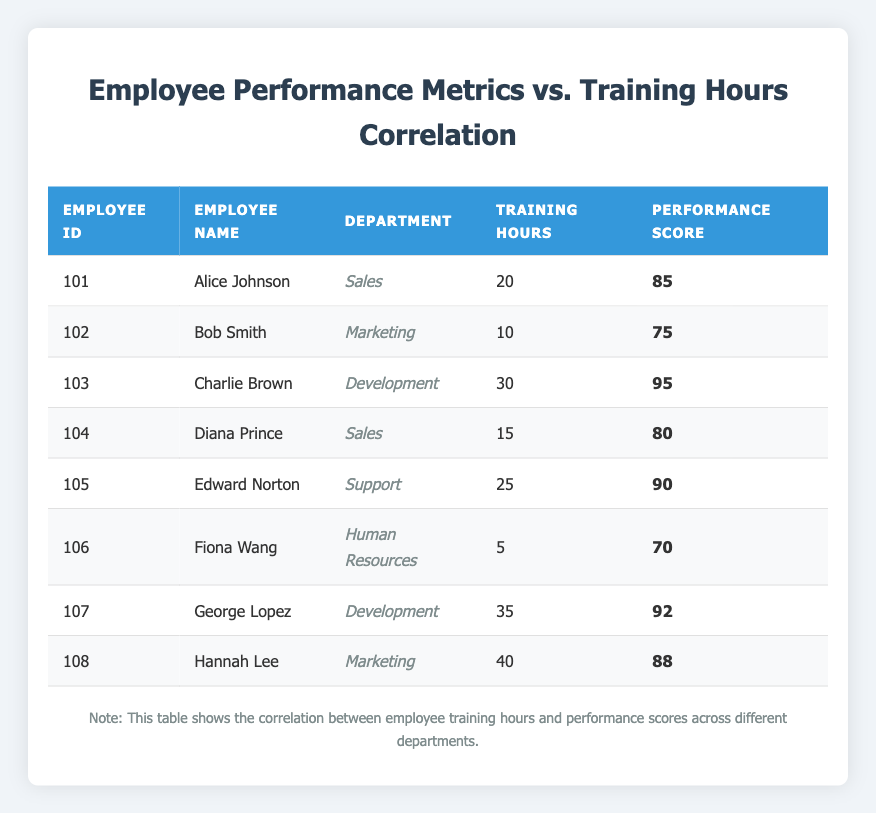What is the Performance Score of Fiona Wang? From the table, look for Fiona Wang's entry, which is listed under Employee ID 106. Her Performance Score is in the corresponding column next to her name. The score is 70.
Answer: 70 What is the Training Hours for the employee with the highest Performance Score? Identify the highest Performance Score in the table, which belongs to Charlie Brown with a score of 95. Next to his name in the Training Hours column, it shows he has 30 Training Hours.
Answer: 30 How many employees have a Performance Score greater than 80? Review the Performance Scores in the table. The employees with scores greater than 80 are: Alice Johnson (85), Charlie Brown (95), Edward Norton (90), George Lopez (92), and Hannah Lee (88). That's a total of 5 employees.
Answer: 5 What are the average Training Hours for employees in the Sales department? Identify the employees in the Sales department, which are Alice Johnson (20 hours) and Diana Prince (15 hours). To find the average, sum their Training Hours (20 + 15 = 35) and divide by the number of employees (2). The average is 35 / 2 = 17.5.
Answer: 17.5 Is George Lopez's Performance Score higher than Bob Smith's? Look at the Performance Scores of George Lopez and Bob Smith from the table. George Lopez has a score of 92 and Bob Smith has a score of 75. Since 92 is greater than 75, the answer is yes.
Answer: Yes How many Training Hours does the employee in Marketing with the lowest Performance Score have? In the Marketing department, identify the employees: Bob Smith has 10 Training Hours and a score of 75, while Hannah Lee has 40 Training Hours with a score of 88. Bob Smith has the lowest score, so we check his Training Hours, which is 10.
Answer: 10 What is the difference in Training Hours between the employee with the highest and lowest Performance Scores? From the table, the highest Performance Score is Charlie Brown with 30 Training Hours, and the lowest Performance Score is Fiona Wang with 5 Training Hours. The difference is calculated as 35 (30 - 5 = 25 hours).
Answer: 25 How many employees have more than 20 Training Hours? Go through the Training Hours column. Employees with more than 20 Training Hours are Charlie Brown (30), Edward Norton (25), George Lopez (35), and Hannah Lee (40). This totals to 4 employees.
Answer: 4 What is the Performance Score of the employee with the most Training Hours? From the table, Hannah Lee has the most Training Hours with 40. Now, check her Performance Score listed next to her Training Hours, which is 88.
Answer: 88 